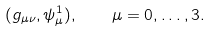<formula> <loc_0><loc_0><loc_500><loc_500>( g _ { \mu \nu } , \psi ^ { 1 } _ { \mu } ) , \quad \mu = 0 , \dots , 3 .</formula> 